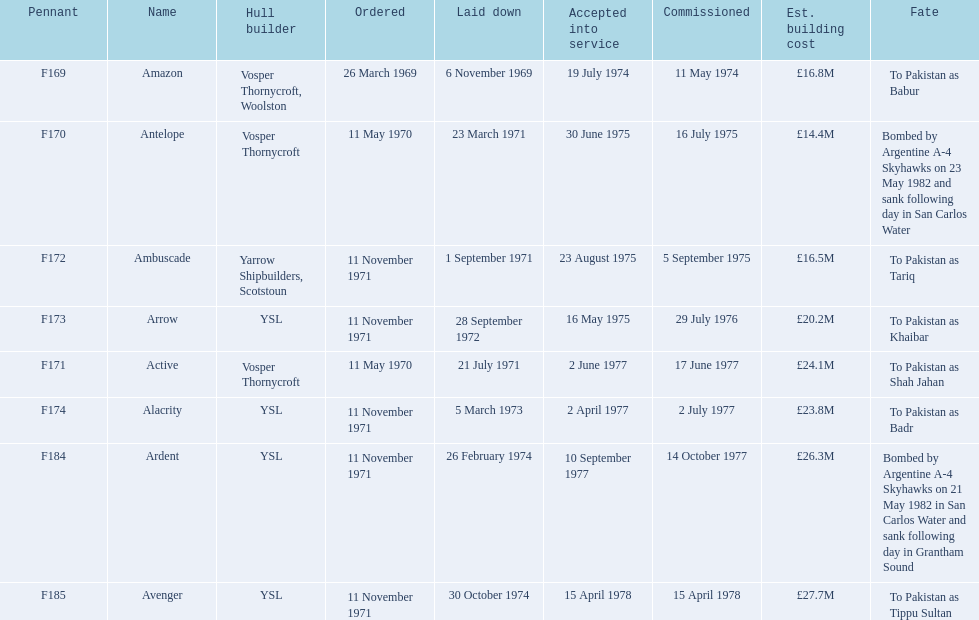What is the last listed pennant? F185. Give me the full table as a dictionary. {'header': ['Pennant', 'Name', 'Hull builder', 'Ordered', 'Laid down', 'Accepted into service', 'Commissioned', 'Est. building cost', 'Fate'], 'rows': [['F169', 'Amazon', 'Vosper Thornycroft, Woolston', '26 March 1969', '6 November 1969', '19 July 1974', '11 May 1974', '£16.8M', 'To Pakistan as Babur'], ['F170', 'Antelope', 'Vosper Thornycroft', '11 May 1970', '23 March 1971', '30 June 1975', '16 July 1975', '£14.4M', 'Bombed by Argentine A-4 Skyhawks on 23 May 1982 and sank following day in San Carlos Water'], ['F172', 'Ambuscade', 'Yarrow Shipbuilders, Scotstoun', '11 November 1971', '1 September 1971', '23 August 1975', '5 September 1975', '£16.5M', 'To Pakistan as Tariq'], ['F173', 'Arrow', 'YSL', '11 November 1971', '28 September 1972', '16 May 1975', '29 July 1976', '£20.2M', 'To Pakistan as Khaibar'], ['F171', 'Active', 'Vosper Thornycroft', '11 May 1970', '21 July 1971', '2 June 1977', '17 June 1977', '£24.1M', 'To Pakistan as Shah Jahan'], ['F174', 'Alacrity', 'YSL', '11 November 1971', '5 March 1973', '2 April 1977', '2 July 1977', '£23.8M', 'To Pakistan as Badr'], ['F184', 'Ardent', 'YSL', '11 November 1971', '26 February 1974', '10 September 1977', '14 October 1977', '£26.3M', 'Bombed by Argentine A-4 Skyhawks on 21 May 1982 in San Carlos Water and sank following day in Grantham Sound'], ['F185', 'Avenger', 'YSL', '11 November 1971', '30 October 1974', '15 April 1978', '15 April 1978', '£27.7M', 'To Pakistan as Tippu Sultan']]} 